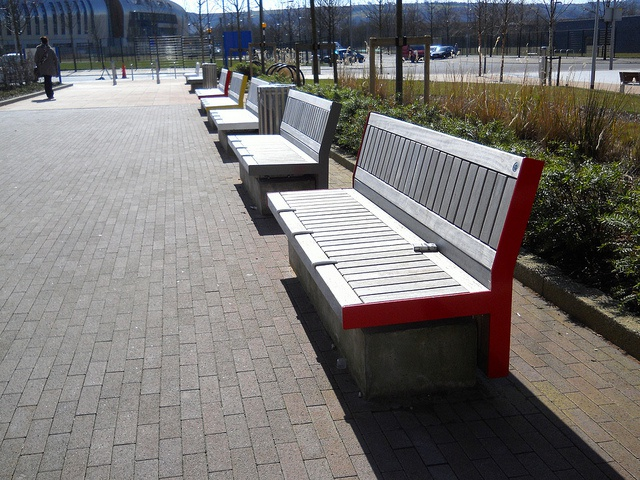Describe the objects in this image and their specific colors. I can see bench in navy, white, maroon, darkgray, and gray tones, bench in navy, white, black, darkgray, and gray tones, bench in navy, white, and gray tones, people in navy, black, gray, and darkblue tones, and bench in navy, white, olive, and gray tones in this image. 